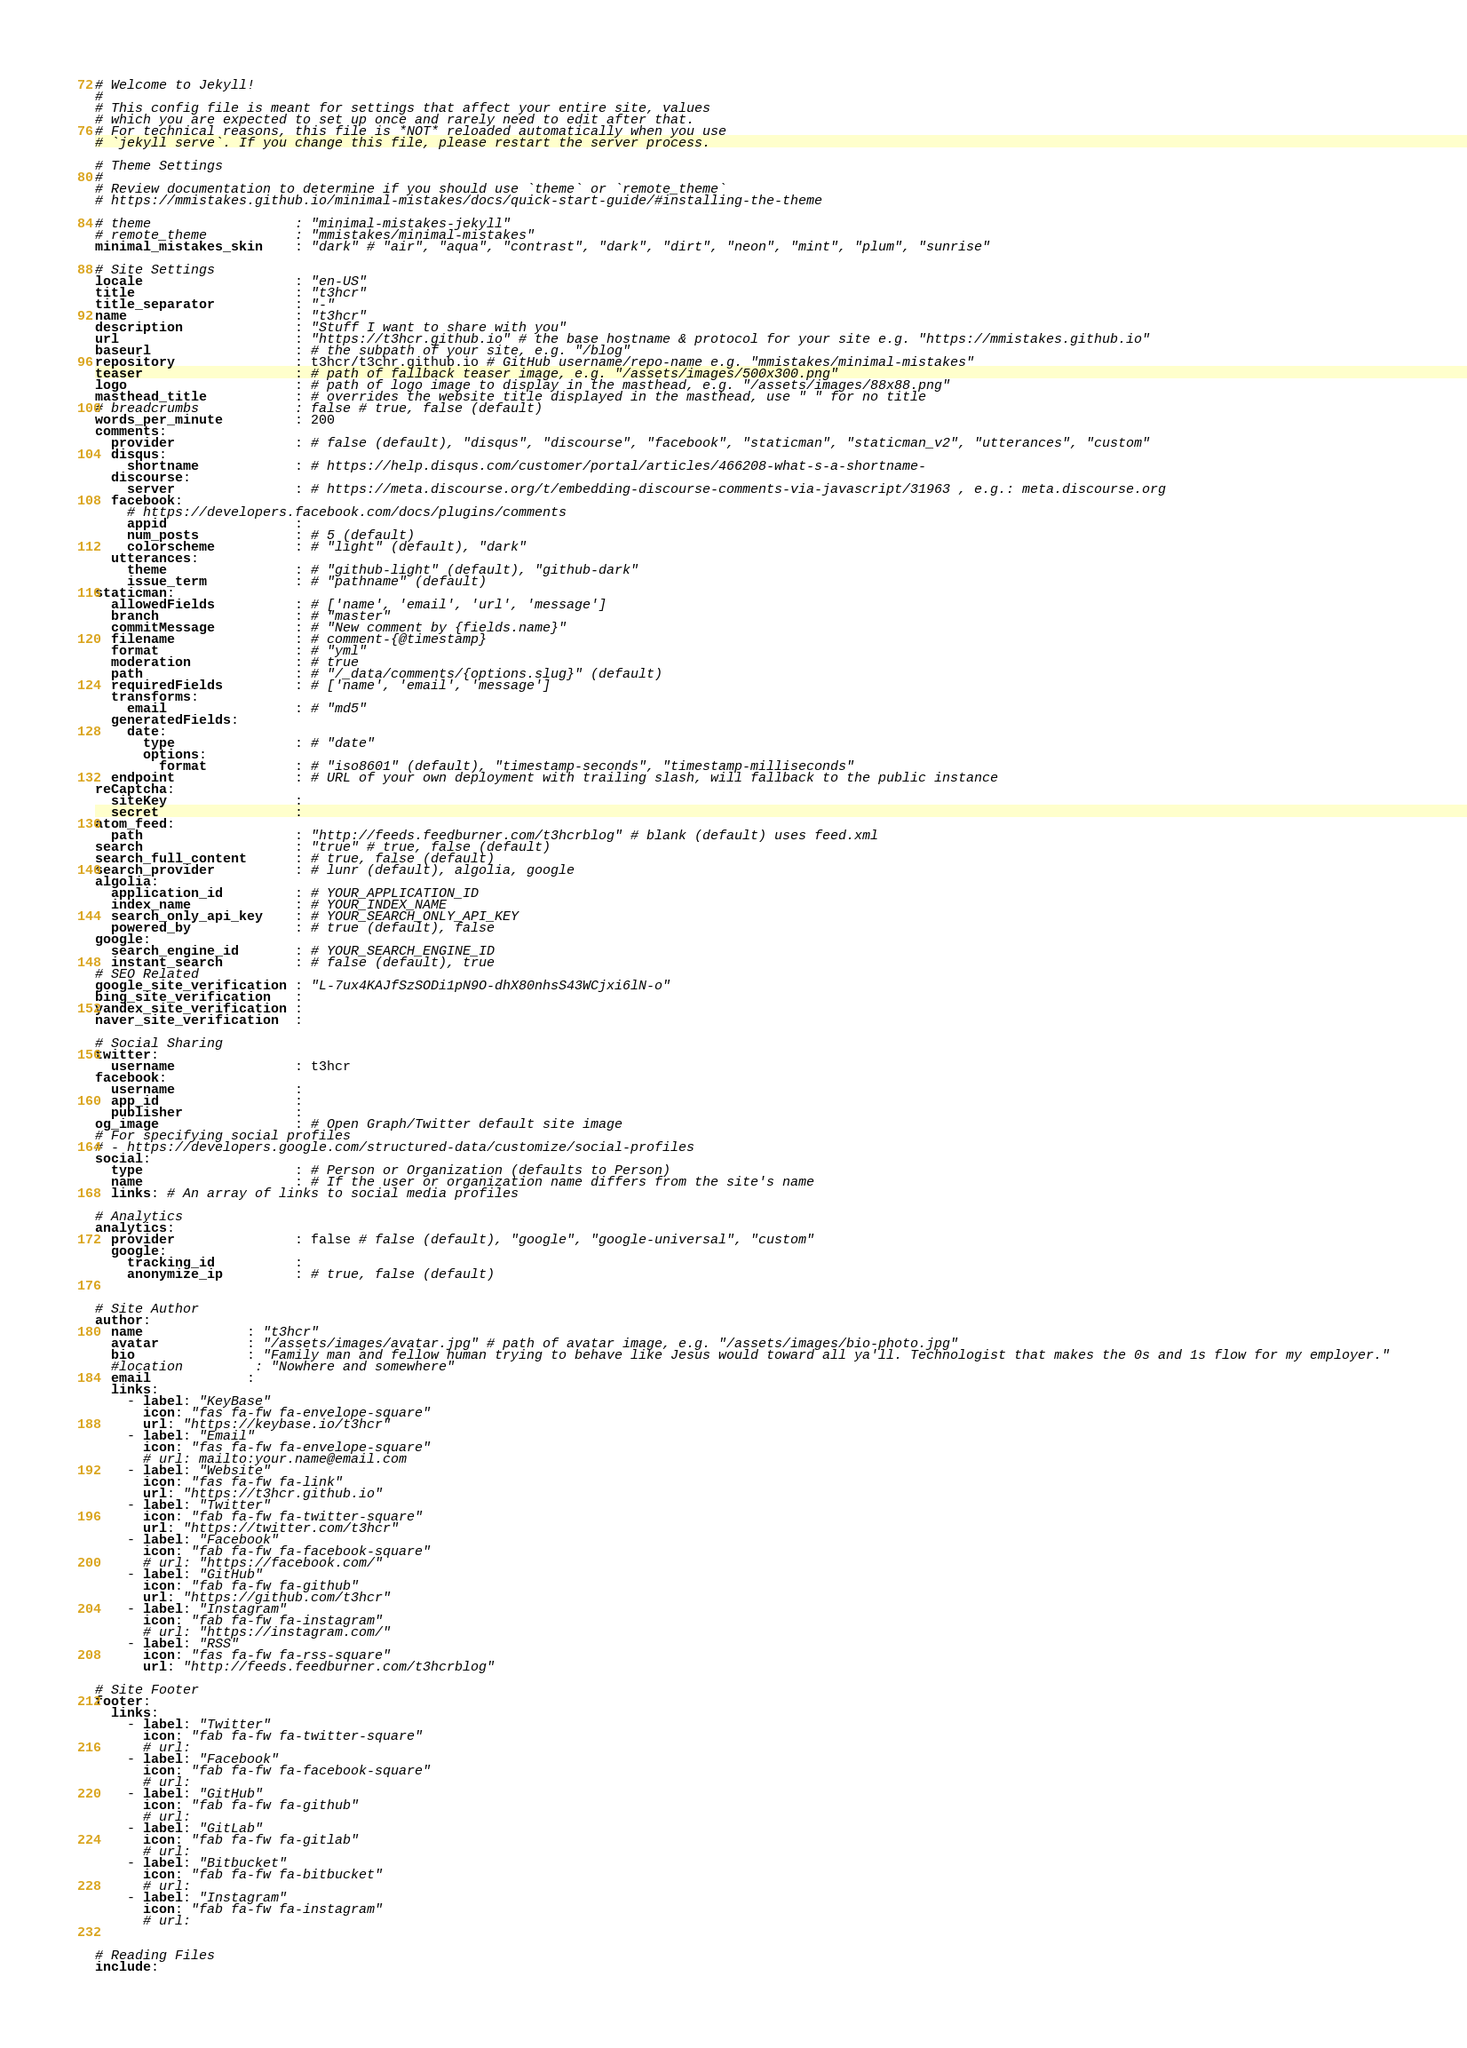<code> <loc_0><loc_0><loc_500><loc_500><_YAML_># Welcome to Jekyll!
#
# This config file is meant for settings that affect your entire site, values
# which you are expected to set up once and rarely need to edit after that.
# For technical reasons, this file is *NOT* reloaded automatically when you use
# `jekyll serve`. If you change this file, please restart the server process.

# Theme Settings
#
# Review documentation to determine if you should use `theme` or `remote_theme`
# https://mmistakes.github.io/minimal-mistakes/docs/quick-start-guide/#installing-the-theme

# theme                  : "minimal-mistakes-jekyll"
# remote_theme           : "mmistakes/minimal-mistakes"
minimal_mistakes_skin    : "dark" # "air", "aqua", "contrast", "dark", "dirt", "neon", "mint", "plum", "sunrise"

# Site Settings
locale                   : "en-US"
title                    : "t3hcr"
title_separator          : "-"
name                     : "t3hcr"
description              : "Stuff I want to share with you"
url                      : "https://t3hcr.github.io" # the base hostname & protocol for your site e.g. "https://mmistakes.github.io"
baseurl                  : # the subpath of your site, e.g. "/blog"
repository               : t3hcr/t3chr.github.io # GitHub username/repo-name e.g. "mmistakes/minimal-mistakes"
teaser                   : # path of fallback teaser image, e.g. "/assets/images/500x300.png"
logo                     : # path of logo image to display in the masthead, e.g. "/assets/images/88x88.png"
masthead_title           : # overrides the website title displayed in the masthead, use " " for no title
# breadcrumbs            : false # true, false (default)
words_per_minute         : 200
comments:
  provider               : # false (default), "disqus", "discourse", "facebook", "staticman", "staticman_v2", "utterances", "custom"
  disqus:
    shortname            : # https://help.disqus.com/customer/portal/articles/466208-what-s-a-shortname-
  discourse:
    server               : # https://meta.discourse.org/t/embedding-discourse-comments-via-javascript/31963 , e.g.: meta.discourse.org
  facebook:
    # https://developers.facebook.com/docs/plugins/comments
    appid                :
    num_posts            : # 5 (default)
    colorscheme          : # "light" (default), "dark"
  utterances:
    theme                : # "github-light" (default), "github-dark"
    issue_term           : # "pathname" (default)
staticman:
  allowedFields          : # ['name', 'email', 'url', 'message']
  branch                 : # "master"
  commitMessage          : # "New comment by {fields.name}"
  filename               : # comment-{@timestamp}
  format                 : # "yml"
  moderation             : # true
  path                   : # "/_data/comments/{options.slug}" (default)
  requiredFields         : # ['name', 'email', 'message']
  transforms:
    email                : # "md5"
  generatedFields:
    date:
      type               : # "date"
      options:
        format           : # "iso8601" (default), "timestamp-seconds", "timestamp-milliseconds"
  endpoint               : # URL of your own deployment with trailing slash, will fallback to the public instance
reCaptcha:
  siteKey                :
  secret                 :
atom_feed:
  path                   : "http://feeds.feedburner.com/t3hcrblog" # blank (default) uses feed.xml
search                   : "true" # true, false (default)
search_full_content      : # true, false (default)
search_provider          : # lunr (default), algolia, google
algolia:
  application_id         : # YOUR_APPLICATION_ID
  index_name             : # YOUR_INDEX_NAME
  search_only_api_key    : # YOUR_SEARCH_ONLY_API_KEY
  powered_by             : # true (default), false
google:
  search_engine_id       : # YOUR_SEARCH_ENGINE_ID
  instant_search         : # false (default), true
# SEO Related
google_site_verification : "L-7ux4KAJfSzSODi1pN9O-dhX80nhsS43WCjxi6lN-o"
bing_site_verification   :
yandex_site_verification :
naver_site_verification  :

# Social Sharing
twitter:
  username               : t3hcr
facebook:
  username               :
  app_id                 :
  publisher              :
og_image                 : # Open Graph/Twitter default site image
# For specifying social profiles
# - https://developers.google.com/structured-data/customize/social-profiles
social:
  type                   : # Person or Organization (defaults to Person)
  name                   : # If the user or organization name differs from the site's name
  links: # An array of links to social media profiles

# Analytics
analytics:
  provider               : false # false (default), "google", "google-universal", "custom"
  google:
    tracking_id          :
    anonymize_ip         : # true, false (default)


# Site Author
author:
  name             : "t3hcr"
  avatar           : "/assets/images/avatar.jpg" # path of avatar image, e.g. "/assets/images/bio-photo.jpg"
  bio              : "Family man and fellow human trying to behave like Jesus would toward all ya'll. Technologist that makes the 0s and 1s flow for my employer."
  #location         : "Nowhere and somewhere"
  email            :
  links:
    - label: "KeyBase"
      icon: "fas fa-fw fa-envelope-square"
      url: "https://keybase.io/t3hcr"
    - label: "Email"
      icon: "fas fa-fw fa-envelope-square"
      # url: mailto:your.name@email.com
    - label: "Website"
      icon: "fas fa-fw fa-link"
      url: "https://t3hcr.github.io"
    - label: "Twitter"
      icon: "fab fa-fw fa-twitter-square"
      url: "https://twitter.com/t3hcr"
    - label: "Facebook"
      icon: "fab fa-fw fa-facebook-square"
      # url: "https://facebook.com/"
    - label: "GitHub"
      icon: "fab fa-fw fa-github"
      url: "https://github.com/t3hcr"
    - label: "Instagram"
      icon: "fab fa-fw fa-instagram"
      # url: "https://instagram.com/"
    - label: "RSS"
      icon: "fas fa-fw fa-rss-square"
      url: "http://feeds.feedburner.com/t3hcrblog"      

# Site Footer
footer:
  links:
    - label: "Twitter"
      icon: "fab fa-fw fa-twitter-square"
      # url:
    - label: "Facebook"
      icon: "fab fa-fw fa-facebook-square"
      # url:
    - label: "GitHub"
      icon: "fab fa-fw fa-github"
      # url:
    - label: "GitLab"
      icon: "fab fa-fw fa-gitlab"
      # url:
    - label: "Bitbucket"
      icon: "fab fa-fw fa-bitbucket"
      # url:
    - label: "Instagram"
      icon: "fab fa-fw fa-instagram"
      # url:


# Reading Files
include:</code> 